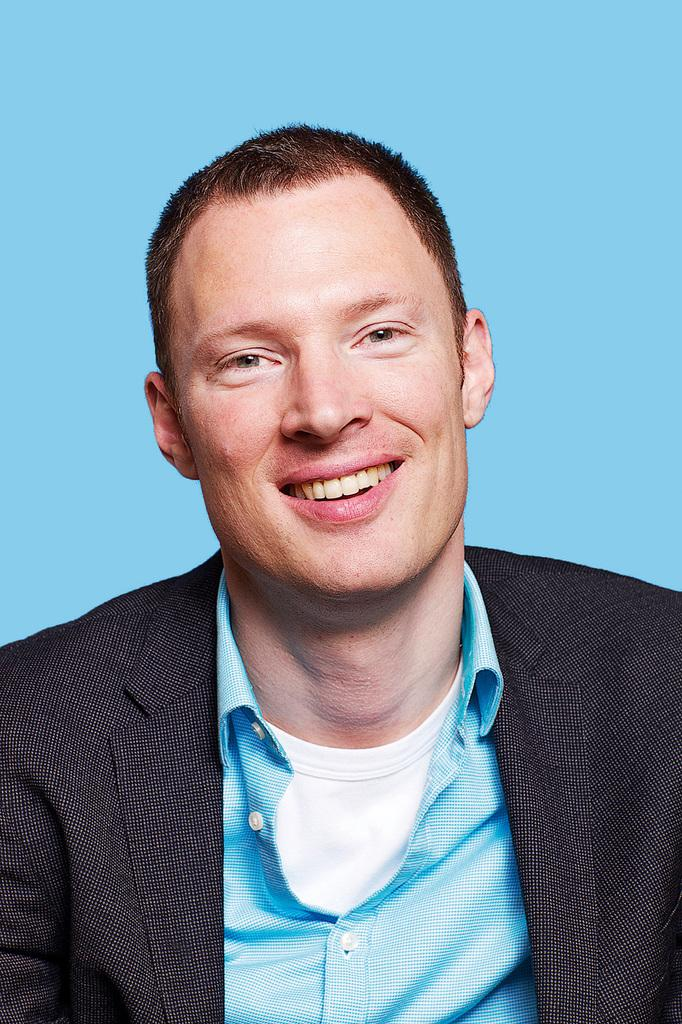What is the main subject of the image? There is a man in the image. What is the man wearing? The man is wearing a black suit and a blue shirt. What color is the background of the image? The background of the image is blue in color. How many hills can be seen in the image? There are no hills present in the image; it features a man in a black suit and blue shirt against a blue background. What day of the week is depicted in the image? The image does not depict a specific day of the week; it is simply a man wearing a black suit and blue shirt against a blue background. 